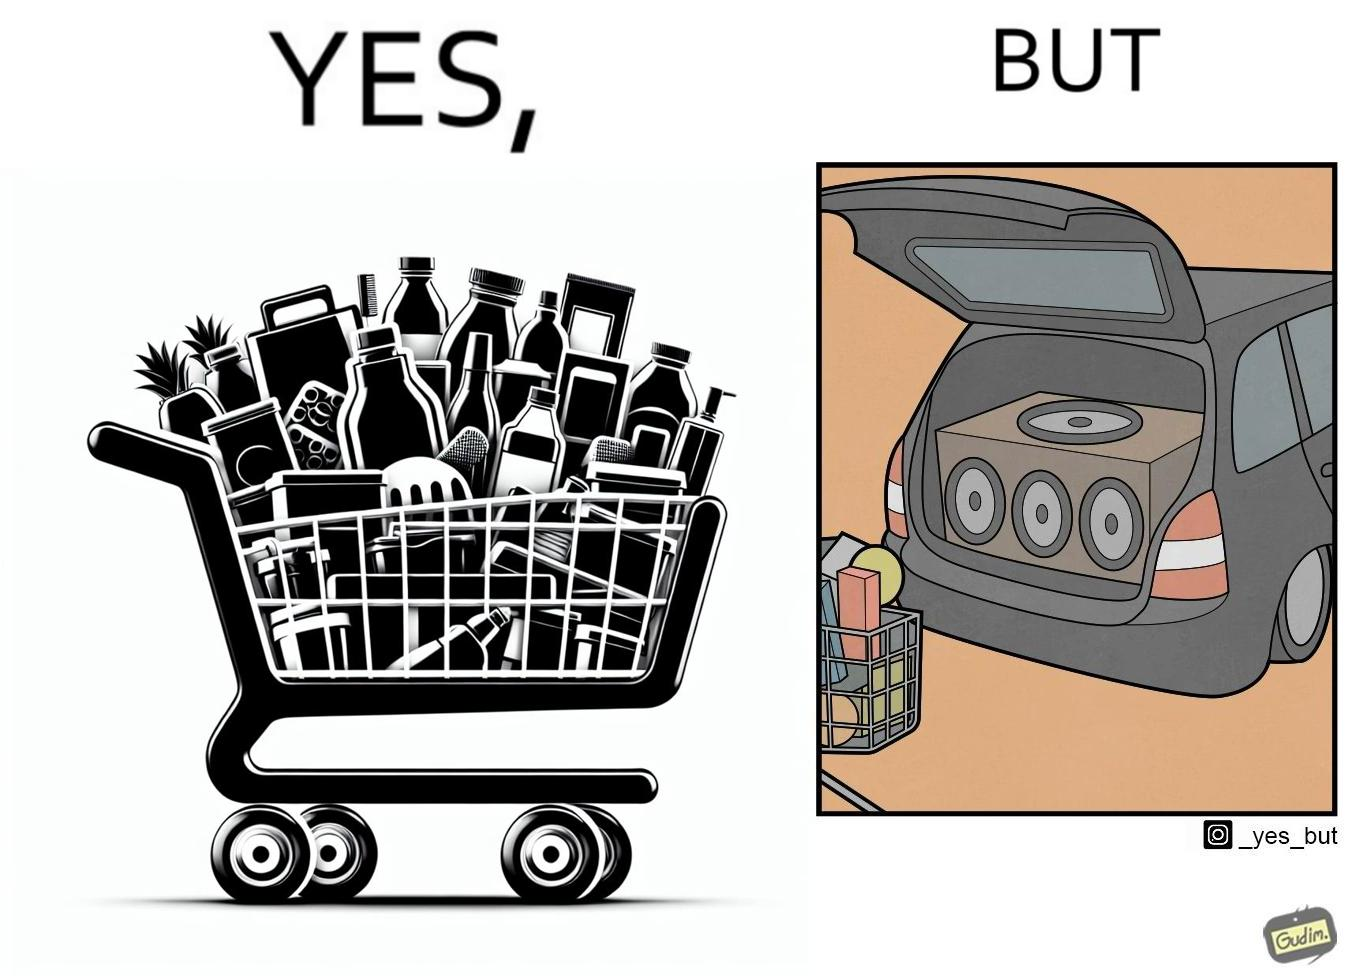Describe the content of this image. The image is ironic, because a car trunk was earlier designed to keep some extra luggage or things but people nowadays get speakers installed in the trunk which in turn reduces the space in the trunk and making it difficult for people to store the extra luggage in the trunk 